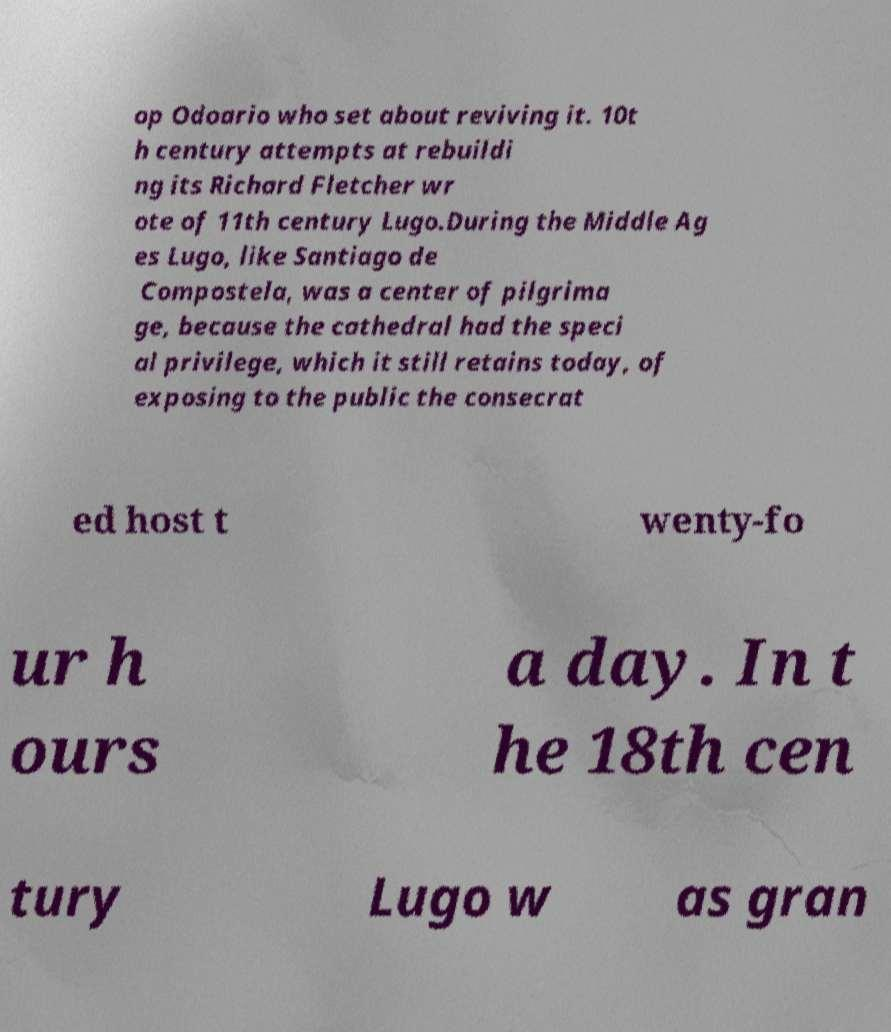Can you accurately transcribe the text from the provided image for me? op Odoario who set about reviving it. 10t h century attempts at rebuildi ng its Richard Fletcher wr ote of 11th century Lugo.During the Middle Ag es Lugo, like Santiago de Compostela, was a center of pilgrima ge, because the cathedral had the speci al privilege, which it still retains today, of exposing to the public the consecrat ed host t wenty-fo ur h ours a day. In t he 18th cen tury Lugo w as gran 